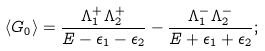<formula> <loc_0><loc_0><loc_500><loc_500>\langle G _ { 0 } \rangle = \frac { \Lambda _ { 1 } ^ { + } \Lambda _ { 2 } ^ { + } } { E - \epsilon _ { 1 } - \epsilon _ { 2 } } - \frac { \Lambda _ { 1 } ^ { - } \Lambda _ { 2 } ^ { - } } { E + \epsilon _ { 1 } + \epsilon _ { 2 } } ;</formula> 